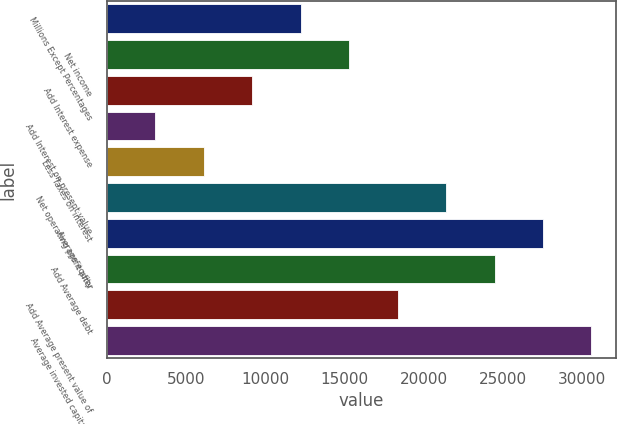Convert chart to OTSL. <chart><loc_0><loc_0><loc_500><loc_500><bar_chart><fcel>Millions Except Percentages<fcel>Net income<fcel>Add Interest expense<fcel>Add Interest on present value<fcel>Less Taxes on interest<fcel>Net operating profit after<fcel>Average equity<fcel>Add Average debt<fcel>Add Average present value of<fcel>Average invested capital as<nl><fcel>12245.4<fcel>15303.7<fcel>9187.18<fcel>3070.66<fcel>6128.92<fcel>21420.2<fcel>27536.7<fcel>24478.5<fcel>18362<fcel>30595<nl></chart> 